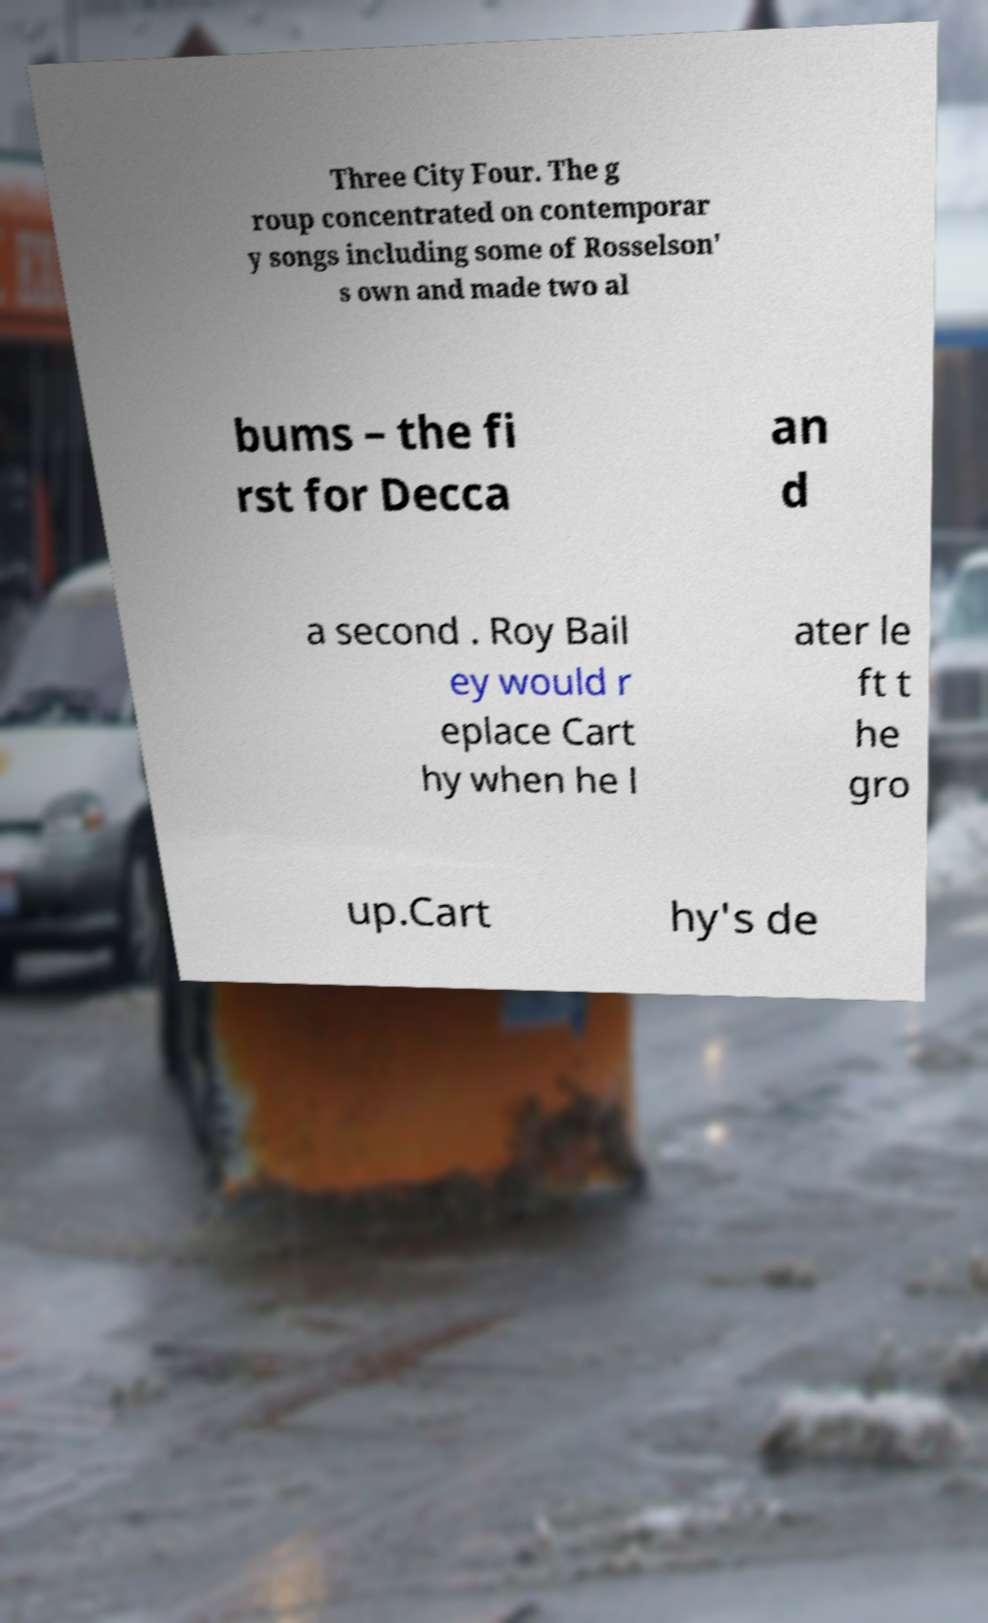Could you assist in decoding the text presented in this image and type it out clearly? Three City Four. The g roup concentrated on contemporar y songs including some of Rosselson' s own and made two al bums – the fi rst for Decca an d a second . Roy Bail ey would r eplace Cart hy when he l ater le ft t he gro up.Cart hy's de 